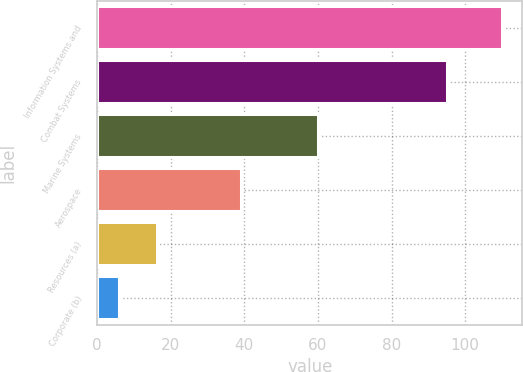Convert chart. <chart><loc_0><loc_0><loc_500><loc_500><bar_chart><fcel>Information Systems and<fcel>Combat Systems<fcel>Marine Systems<fcel>Aerospace<fcel>Resources (a)<fcel>Corporate (b)<nl><fcel>110<fcel>95<fcel>60<fcel>39<fcel>16.4<fcel>6<nl></chart> 